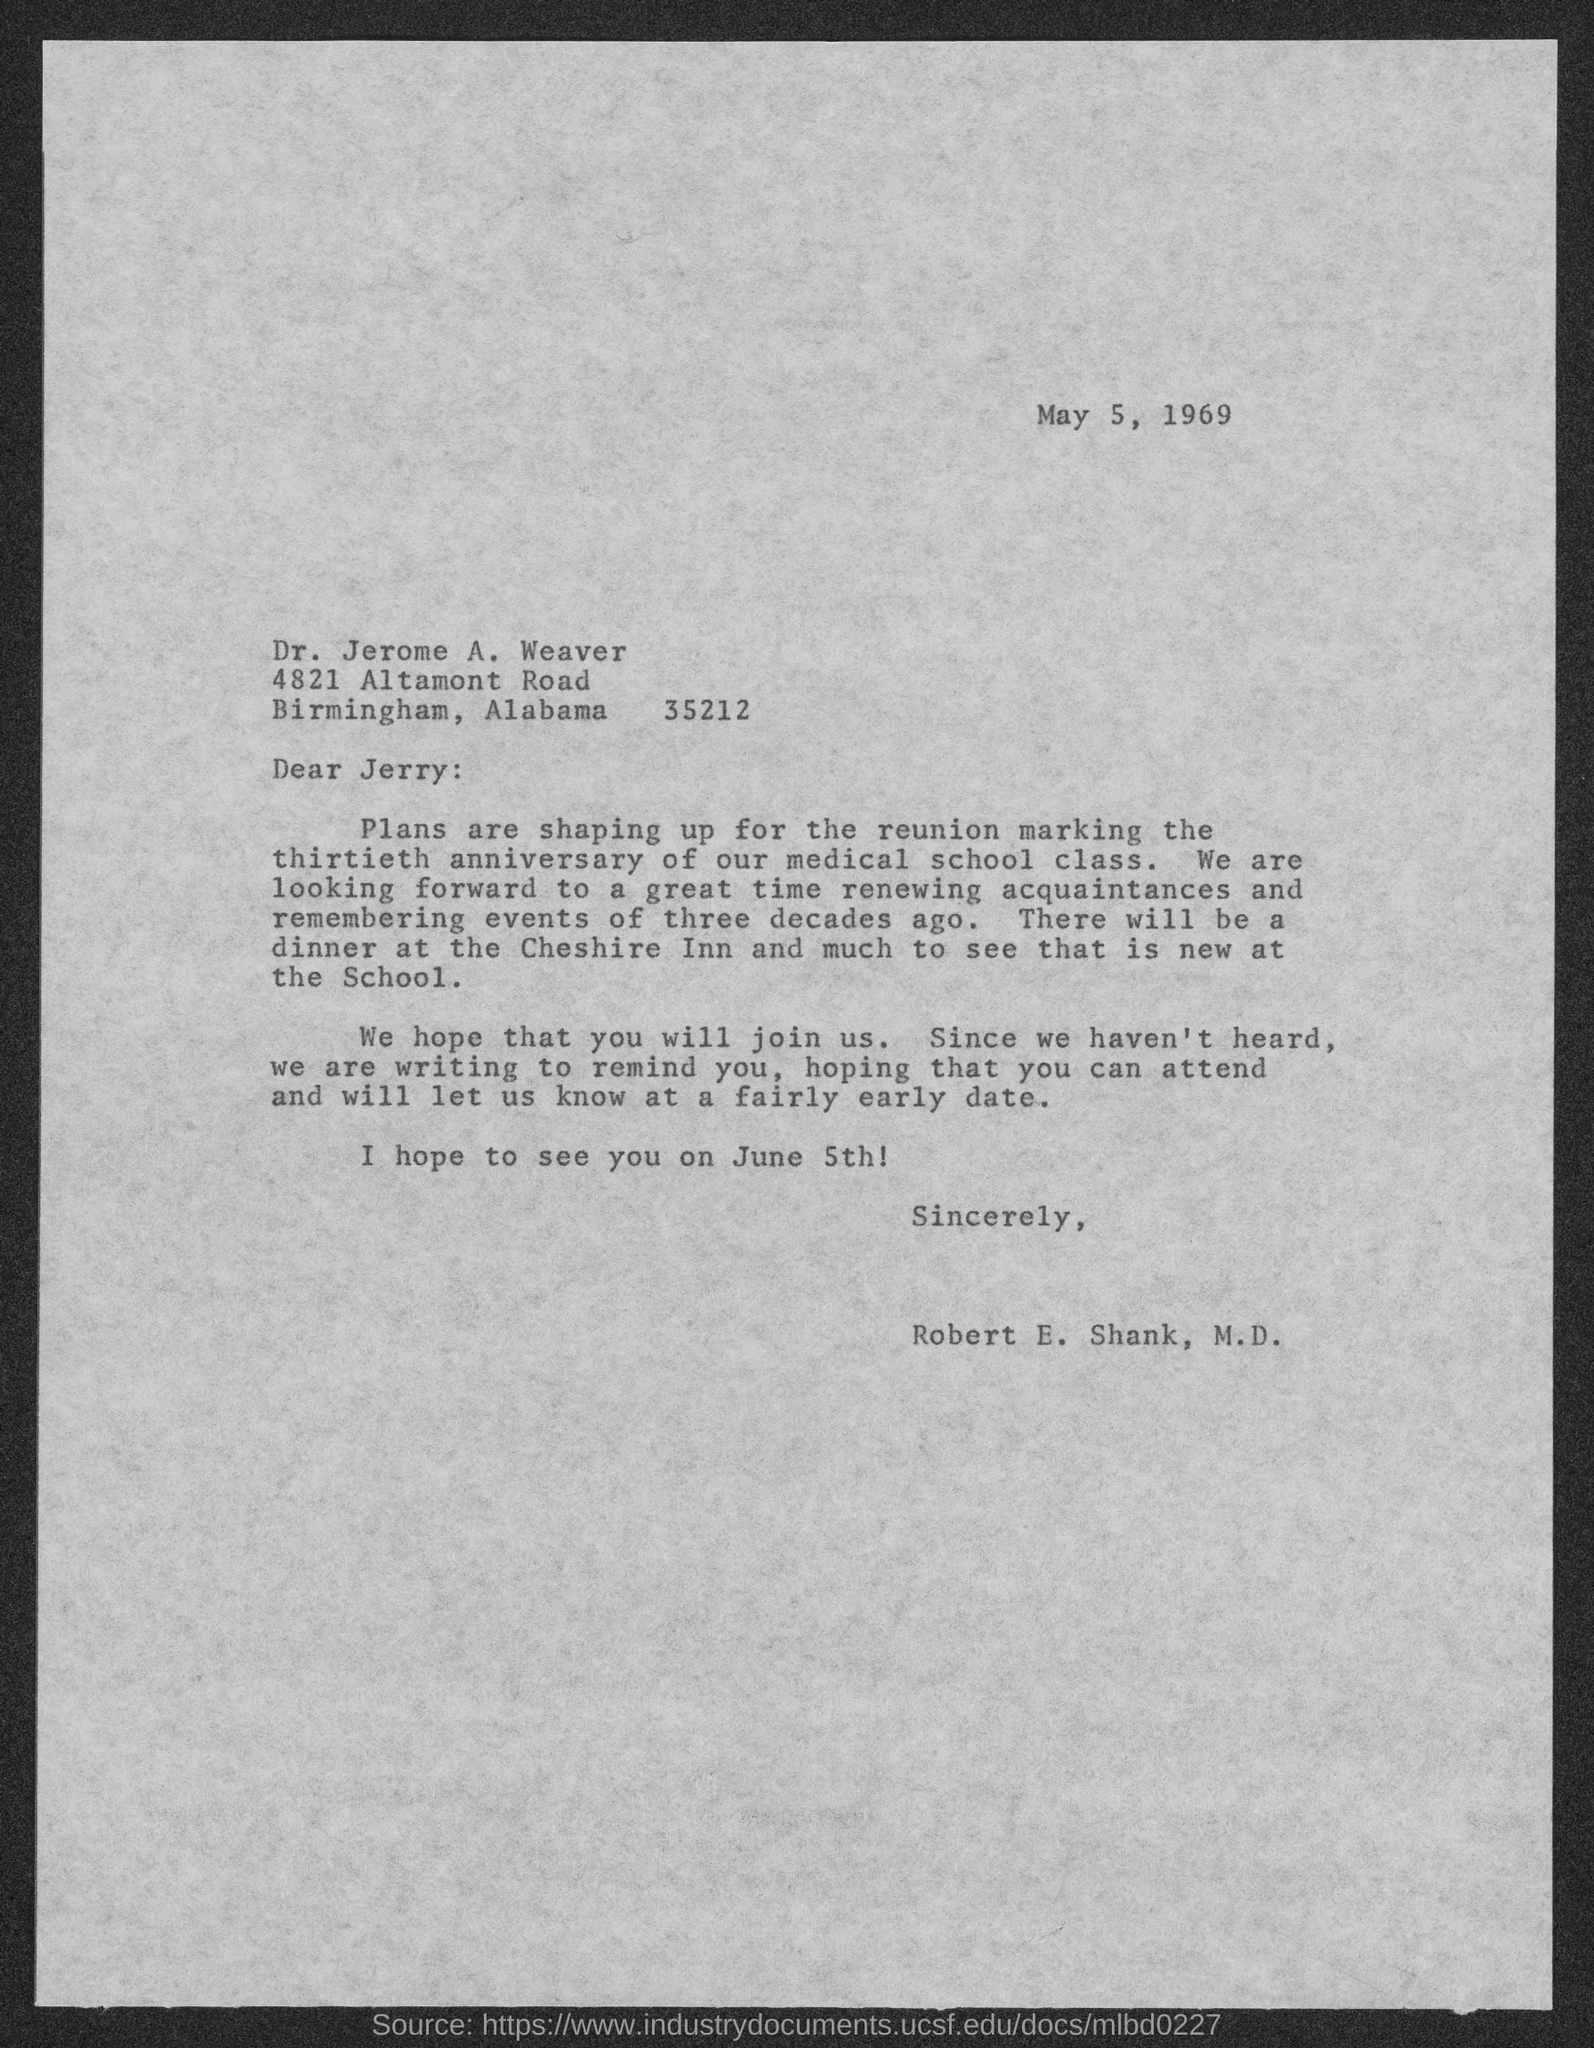Outline some significant characteristics in this image. The occasion for the reunion is to mark the thirtieth anniversary of our medical school class. The letter is addressed to Jerry. The reunion will take place on June 5th. The document is dated May 5, 1969. The sender is Robert E. Shank, M.D. 